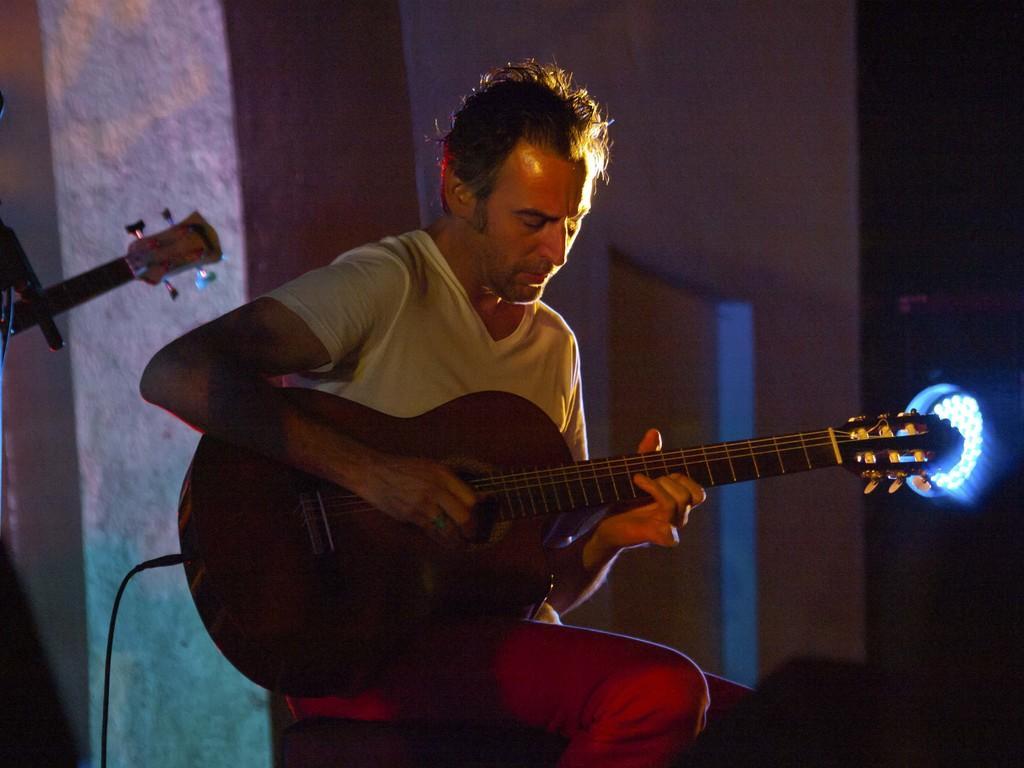Please provide a concise description of this image. In this picture there is a man with white t-shirt sitting and playing guitar. At the right side of the image there is a light. 